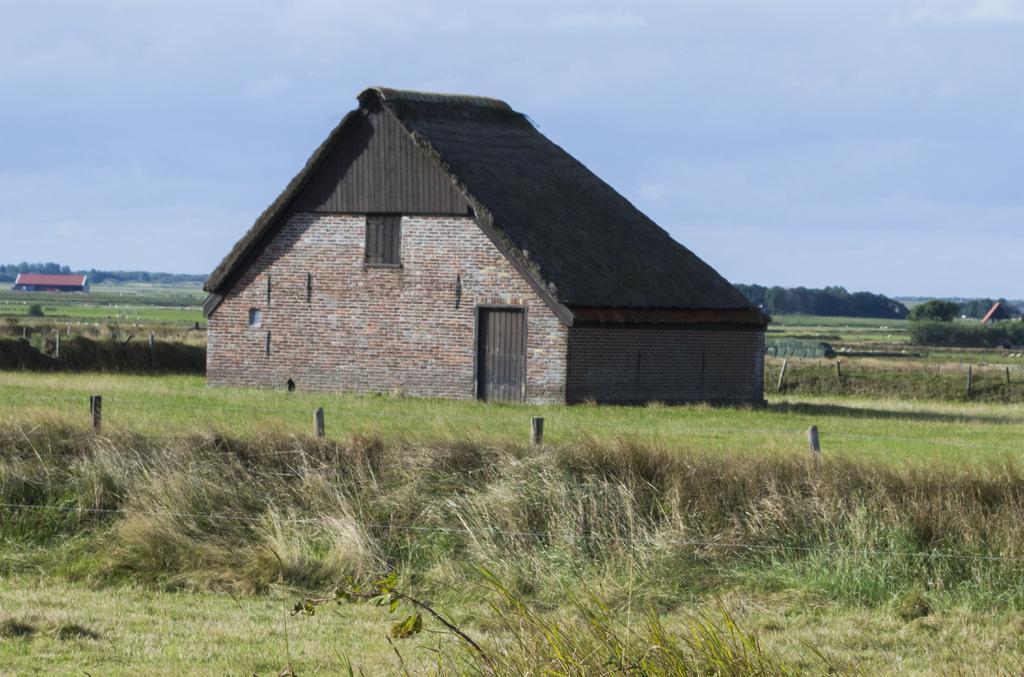Can you describe this image briefly? In this image we can see a building with door. On the ground there is grass. There are poles. In the background there are trees. Also we can see a building and there is sky with clouds. 